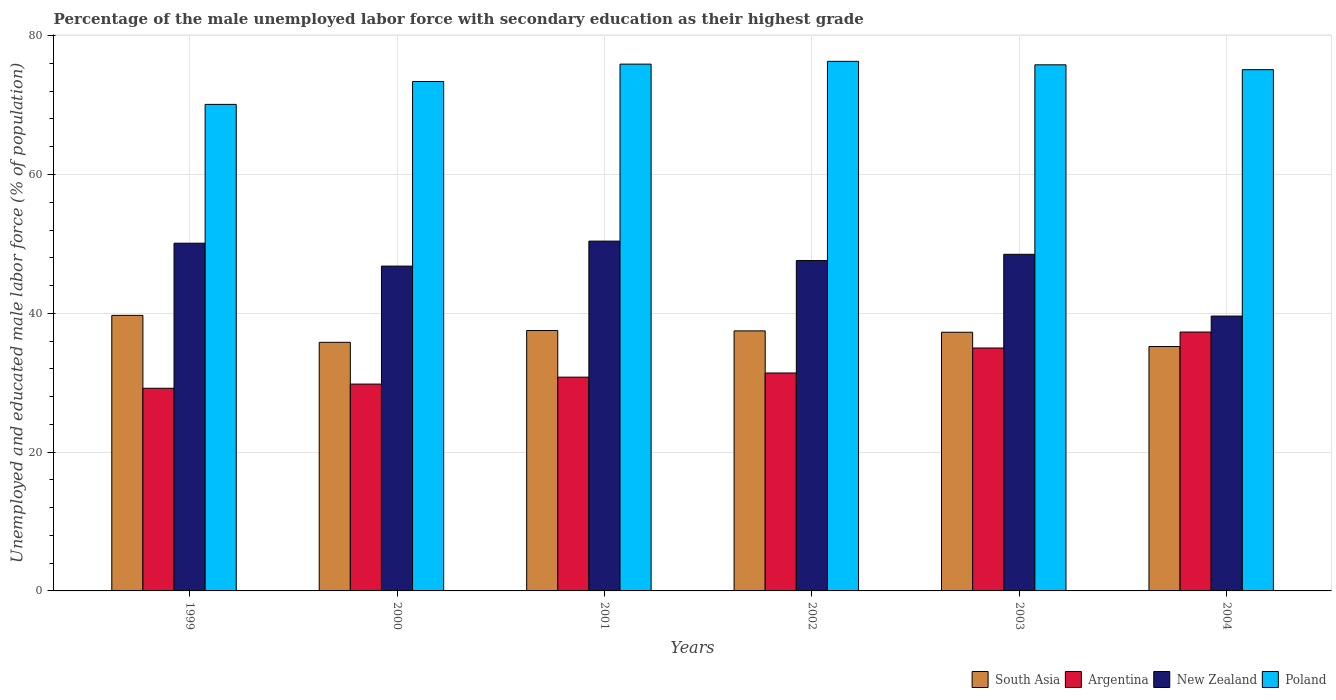Are the number of bars per tick equal to the number of legend labels?
Your answer should be compact. Yes. How many bars are there on the 5th tick from the left?
Your answer should be very brief. 4. What is the label of the 4th group of bars from the left?
Provide a short and direct response. 2002. What is the percentage of the unemployed male labor force with secondary education in South Asia in 2003?
Give a very brief answer. 37.27. Across all years, what is the maximum percentage of the unemployed male labor force with secondary education in South Asia?
Your response must be concise. 39.7. Across all years, what is the minimum percentage of the unemployed male labor force with secondary education in New Zealand?
Provide a succinct answer. 39.6. What is the total percentage of the unemployed male labor force with secondary education in Argentina in the graph?
Your answer should be very brief. 193.5. What is the difference between the percentage of the unemployed male labor force with secondary education in Argentina in 1999 and that in 2000?
Give a very brief answer. -0.6. What is the difference between the percentage of the unemployed male labor force with secondary education in South Asia in 2002 and the percentage of the unemployed male labor force with secondary education in Poland in 2004?
Keep it short and to the point. -37.63. What is the average percentage of the unemployed male labor force with secondary education in New Zealand per year?
Offer a very short reply. 47.17. In the year 2004, what is the difference between the percentage of the unemployed male labor force with secondary education in South Asia and percentage of the unemployed male labor force with secondary education in New Zealand?
Offer a very short reply. -4.39. What is the ratio of the percentage of the unemployed male labor force with secondary education in New Zealand in 1999 to that in 2004?
Your answer should be compact. 1.27. Is the percentage of the unemployed male labor force with secondary education in Poland in 1999 less than that in 2001?
Make the answer very short. Yes. What is the difference between the highest and the second highest percentage of the unemployed male labor force with secondary education in Poland?
Offer a very short reply. 0.4. What is the difference between the highest and the lowest percentage of the unemployed male labor force with secondary education in South Asia?
Offer a very short reply. 4.49. What does the 3rd bar from the left in 2003 represents?
Provide a short and direct response. New Zealand. What does the 2nd bar from the right in 2000 represents?
Give a very brief answer. New Zealand. How many bars are there?
Offer a very short reply. 24. How many years are there in the graph?
Provide a succinct answer. 6. Are the values on the major ticks of Y-axis written in scientific E-notation?
Your response must be concise. No. Does the graph contain any zero values?
Your answer should be very brief. No. Where does the legend appear in the graph?
Your response must be concise. Bottom right. What is the title of the graph?
Your answer should be compact. Percentage of the male unemployed labor force with secondary education as their highest grade. Does "Cabo Verde" appear as one of the legend labels in the graph?
Provide a succinct answer. No. What is the label or title of the Y-axis?
Provide a succinct answer. Unemployed and educated male labor force (% of population). What is the Unemployed and educated male labor force (% of population) of South Asia in 1999?
Offer a very short reply. 39.7. What is the Unemployed and educated male labor force (% of population) of Argentina in 1999?
Your answer should be compact. 29.2. What is the Unemployed and educated male labor force (% of population) in New Zealand in 1999?
Ensure brevity in your answer.  50.1. What is the Unemployed and educated male labor force (% of population) of Poland in 1999?
Provide a short and direct response. 70.1. What is the Unemployed and educated male labor force (% of population) of South Asia in 2000?
Your answer should be very brief. 35.82. What is the Unemployed and educated male labor force (% of population) of Argentina in 2000?
Offer a very short reply. 29.8. What is the Unemployed and educated male labor force (% of population) of New Zealand in 2000?
Your answer should be very brief. 46.8. What is the Unemployed and educated male labor force (% of population) in Poland in 2000?
Make the answer very short. 73.4. What is the Unemployed and educated male labor force (% of population) of South Asia in 2001?
Give a very brief answer. 37.52. What is the Unemployed and educated male labor force (% of population) of Argentina in 2001?
Provide a succinct answer. 30.8. What is the Unemployed and educated male labor force (% of population) of New Zealand in 2001?
Your answer should be very brief. 50.4. What is the Unemployed and educated male labor force (% of population) of Poland in 2001?
Keep it short and to the point. 75.9. What is the Unemployed and educated male labor force (% of population) of South Asia in 2002?
Keep it short and to the point. 37.47. What is the Unemployed and educated male labor force (% of population) of Argentina in 2002?
Offer a very short reply. 31.4. What is the Unemployed and educated male labor force (% of population) of New Zealand in 2002?
Ensure brevity in your answer.  47.6. What is the Unemployed and educated male labor force (% of population) in Poland in 2002?
Your answer should be very brief. 76.3. What is the Unemployed and educated male labor force (% of population) in South Asia in 2003?
Ensure brevity in your answer.  37.27. What is the Unemployed and educated male labor force (% of population) of New Zealand in 2003?
Your response must be concise. 48.5. What is the Unemployed and educated male labor force (% of population) in Poland in 2003?
Your response must be concise. 75.8. What is the Unemployed and educated male labor force (% of population) of South Asia in 2004?
Your answer should be very brief. 35.21. What is the Unemployed and educated male labor force (% of population) of Argentina in 2004?
Make the answer very short. 37.3. What is the Unemployed and educated male labor force (% of population) of New Zealand in 2004?
Give a very brief answer. 39.6. What is the Unemployed and educated male labor force (% of population) of Poland in 2004?
Your answer should be very brief. 75.1. Across all years, what is the maximum Unemployed and educated male labor force (% of population) of South Asia?
Provide a succinct answer. 39.7. Across all years, what is the maximum Unemployed and educated male labor force (% of population) of Argentina?
Provide a succinct answer. 37.3. Across all years, what is the maximum Unemployed and educated male labor force (% of population) of New Zealand?
Your response must be concise. 50.4. Across all years, what is the maximum Unemployed and educated male labor force (% of population) of Poland?
Make the answer very short. 76.3. Across all years, what is the minimum Unemployed and educated male labor force (% of population) of South Asia?
Offer a terse response. 35.21. Across all years, what is the minimum Unemployed and educated male labor force (% of population) of Argentina?
Make the answer very short. 29.2. Across all years, what is the minimum Unemployed and educated male labor force (% of population) in New Zealand?
Offer a terse response. 39.6. Across all years, what is the minimum Unemployed and educated male labor force (% of population) in Poland?
Provide a short and direct response. 70.1. What is the total Unemployed and educated male labor force (% of population) of South Asia in the graph?
Provide a succinct answer. 222.98. What is the total Unemployed and educated male labor force (% of population) in Argentina in the graph?
Make the answer very short. 193.5. What is the total Unemployed and educated male labor force (% of population) in New Zealand in the graph?
Ensure brevity in your answer.  283. What is the total Unemployed and educated male labor force (% of population) of Poland in the graph?
Provide a short and direct response. 446.6. What is the difference between the Unemployed and educated male labor force (% of population) of South Asia in 1999 and that in 2000?
Keep it short and to the point. 3.88. What is the difference between the Unemployed and educated male labor force (% of population) of Argentina in 1999 and that in 2000?
Keep it short and to the point. -0.6. What is the difference between the Unemployed and educated male labor force (% of population) of New Zealand in 1999 and that in 2000?
Keep it short and to the point. 3.3. What is the difference between the Unemployed and educated male labor force (% of population) of South Asia in 1999 and that in 2001?
Keep it short and to the point. 2.19. What is the difference between the Unemployed and educated male labor force (% of population) of South Asia in 1999 and that in 2002?
Offer a very short reply. 2.23. What is the difference between the Unemployed and educated male labor force (% of population) in Argentina in 1999 and that in 2002?
Give a very brief answer. -2.2. What is the difference between the Unemployed and educated male labor force (% of population) of New Zealand in 1999 and that in 2002?
Keep it short and to the point. 2.5. What is the difference between the Unemployed and educated male labor force (% of population) of Poland in 1999 and that in 2002?
Keep it short and to the point. -6.2. What is the difference between the Unemployed and educated male labor force (% of population) in South Asia in 1999 and that in 2003?
Keep it short and to the point. 2.43. What is the difference between the Unemployed and educated male labor force (% of population) in Argentina in 1999 and that in 2003?
Keep it short and to the point. -5.8. What is the difference between the Unemployed and educated male labor force (% of population) of South Asia in 1999 and that in 2004?
Keep it short and to the point. 4.49. What is the difference between the Unemployed and educated male labor force (% of population) of Poland in 1999 and that in 2004?
Keep it short and to the point. -5. What is the difference between the Unemployed and educated male labor force (% of population) in South Asia in 2000 and that in 2001?
Provide a succinct answer. -1.7. What is the difference between the Unemployed and educated male labor force (% of population) of Poland in 2000 and that in 2001?
Your answer should be compact. -2.5. What is the difference between the Unemployed and educated male labor force (% of population) of South Asia in 2000 and that in 2002?
Provide a succinct answer. -1.65. What is the difference between the Unemployed and educated male labor force (% of population) of South Asia in 2000 and that in 2003?
Your answer should be compact. -1.45. What is the difference between the Unemployed and educated male labor force (% of population) in South Asia in 2000 and that in 2004?
Your response must be concise. 0.6. What is the difference between the Unemployed and educated male labor force (% of population) in Argentina in 2000 and that in 2004?
Provide a short and direct response. -7.5. What is the difference between the Unemployed and educated male labor force (% of population) of New Zealand in 2000 and that in 2004?
Offer a terse response. 7.2. What is the difference between the Unemployed and educated male labor force (% of population) in Poland in 2000 and that in 2004?
Provide a succinct answer. -1.7. What is the difference between the Unemployed and educated male labor force (% of population) of South Asia in 2001 and that in 2002?
Ensure brevity in your answer.  0.05. What is the difference between the Unemployed and educated male labor force (% of population) of Argentina in 2001 and that in 2002?
Provide a succinct answer. -0.6. What is the difference between the Unemployed and educated male labor force (% of population) in Poland in 2001 and that in 2002?
Offer a very short reply. -0.4. What is the difference between the Unemployed and educated male labor force (% of population) of South Asia in 2001 and that in 2003?
Keep it short and to the point. 0.25. What is the difference between the Unemployed and educated male labor force (% of population) of Poland in 2001 and that in 2003?
Ensure brevity in your answer.  0.1. What is the difference between the Unemployed and educated male labor force (% of population) in South Asia in 2001 and that in 2004?
Provide a succinct answer. 2.3. What is the difference between the Unemployed and educated male labor force (% of population) of Argentina in 2001 and that in 2004?
Your response must be concise. -6.5. What is the difference between the Unemployed and educated male labor force (% of population) in New Zealand in 2001 and that in 2004?
Offer a terse response. 10.8. What is the difference between the Unemployed and educated male labor force (% of population) in South Asia in 2002 and that in 2003?
Ensure brevity in your answer.  0.2. What is the difference between the Unemployed and educated male labor force (% of population) in New Zealand in 2002 and that in 2003?
Provide a short and direct response. -0.9. What is the difference between the Unemployed and educated male labor force (% of population) of Poland in 2002 and that in 2003?
Offer a very short reply. 0.5. What is the difference between the Unemployed and educated male labor force (% of population) of South Asia in 2002 and that in 2004?
Provide a succinct answer. 2.25. What is the difference between the Unemployed and educated male labor force (% of population) in New Zealand in 2002 and that in 2004?
Offer a very short reply. 8. What is the difference between the Unemployed and educated male labor force (% of population) of Poland in 2002 and that in 2004?
Your answer should be compact. 1.2. What is the difference between the Unemployed and educated male labor force (% of population) in South Asia in 2003 and that in 2004?
Provide a short and direct response. 2.05. What is the difference between the Unemployed and educated male labor force (% of population) in South Asia in 1999 and the Unemployed and educated male labor force (% of population) in New Zealand in 2000?
Your answer should be very brief. -7.1. What is the difference between the Unemployed and educated male labor force (% of population) of South Asia in 1999 and the Unemployed and educated male labor force (% of population) of Poland in 2000?
Provide a succinct answer. -33.7. What is the difference between the Unemployed and educated male labor force (% of population) in Argentina in 1999 and the Unemployed and educated male labor force (% of population) in New Zealand in 2000?
Make the answer very short. -17.6. What is the difference between the Unemployed and educated male labor force (% of population) in Argentina in 1999 and the Unemployed and educated male labor force (% of population) in Poland in 2000?
Your response must be concise. -44.2. What is the difference between the Unemployed and educated male labor force (% of population) in New Zealand in 1999 and the Unemployed and educated male labor force (% of population) in Poland in 2000?
Your answer should be compact. -23.3. What is the difference between the Unemployed and educated male labor force (% of population) of South Asia in 1999 and the Unemployed and educated male labor force (% of population) of Poland in 2001?
Provide a succinct answer. -36.2. What is the difference between the Unemployed and educated male labor force (% of population) in Argentina in 1999 and the Unemployed and educated male labor force (% of population) in New Zealand in 2001?
Your response must be concise. -21.2. What is the difference between the Unemployed and educated male labor force (% of population) of Argentina in 1999 and the Unemployed and educated male labor force (% of population) of Poland in 2001?
Offer a terse response. -46.7. What is the difference between the Unemployed and educated male labor force (% of population) of New Zealand in 1999 and the Unemployed and educated male labor force (% of population) of Poland in 2001?
Keep it short and to the point. -25.8. What is the difference between the Unemployed and educated male labor force (% of population) in South Asia in 1999 and the Unemployed and educated male labor force (% of population) in Argentina in 2002?
Offer a terse response. 8.3. What is the difference between the Unemployed and educated male labor force (% of population) of South Asia in 1999 and the Unemployed and educated male labor force (% of population) of Poland in 2002?
Ensure brevity in your answer.  -36.6. What is the difference between the Unemployed and educated male labor force (% of population) in Argentina in 1999 and the Unemployed and educated male labor force (% of population) in New Zealand in 2002?
Provide a succinct answer. -18.4. What is the difference between the Unemployed and educated male labor force (% of population) in Argentina in 1999 and the Unemployed and educated male labor force (% of population) in Poland in 2002?
Your answer should be very brief. -47.1. What is the difference between the Unemployed and educated male labor force (% of population) of New Zealand in 1999 and the Unemployed and educated male labor force (% of population) of Poland in 2002?
Offer a very short reply. -26.2. What is the difference between the Unemployed and educated male labor force (% of population) in South Asia in 1999 and the Unemployed and educated male labor force (% of population) in Poland in 2003?
Your response must be concise. -36.1. What is the difference between the Unemployed and educated male labor force (% of population) of Argentina in 1999 and the Unemployed and educated male labor force (% of population) of New Zealand in 2003?
Your answer should be compact. -19.3. What is the difference between the Unemployed and educated male labor force (% of population) in Argentina in 1999 and the Unemployed and educated male labor force (% of population) in Poland in 2003?
Your answer should be very brief. -46.6. What is the difference between the Unemployed and educated male labor force (% of population) of New Zealand in 1999 and the Unemployed and educated male labor force (% of population) of Poland in 2003?
Your answer should be very brief. -25.7. What is the difference between the Unemployed and educated male labor force (% of population) of South Asia in 1999 and the Unemployed and educated male labor force (% of population) of New Zealand in 2004?
Ensure brevity in your answer.  0.1. What is the difference between the Unemployed and educated male labor force (% of population) of South Asia in 1999 and the Unemployed and educated male labor force (% of population) of Poland in 2004?
Provide a short and direct response. -35.4. What is the difference between the Unemployed and educated male labor force (% of population) in Argentina in 1999 and the Unemployed and educated male labor force (% of population) in Poland in 2004?
Keep it short and to the point. -45.9. What is the difference between the Unemployed and educated male labor force (% of population) of South Asia in 2000 and the Unemployed and educated male labor force (% of population) of Argentina in 2001?
Your answer should be very brief. 5.02. What is the difference between the Unemployed and educated male labor force (% of population) of South Asia in 2000 and the Unemployed and educated male labor force (% of population) of New Zealand in 2001?
Offer a very short reply. -14.58. What is the difference between the Unemployed and educated male labor force (% of population) of South Asia in 2000 and the Unemployed and educated male labor force (% of population) of Poland in 2001?
Offer a terse response. -40.08. What is the difference between the Unemployed and educated male labor force (% of population) of Argentina in 2000 and the Unemployed and educated male labor force (% of population) of New Zealand in 2001?
Give a very brief answer. -20.6. What is the difference between the Unemployed and educated male labor force (% of population) of Argentina in 2000 and the Unemployed and educated male labor force (% of population) of Poland in 2001?
Make the answer very short. -46.1. What is the difference between the Unemployed and educated male labor force (% of population) of New Zealand in 2000 and the Unemployed and educated male labor force (% of population) of Poland in 2001?
Your response must be concise. -29.1. What is the difference between the Unemployed and educated male labor force (% of population) in South Asia in 2000 and the Unemployed and educated male labor force (% of population) in Argentina in 2002?
Make the answer very short. 4.42. What is the difference between the Unemployed and educated male labor force (% of population) in South Asia in 2000 and the Unemployed and educated male labor force (% of population) in New Zealand in 2002?
Your answer should be very brief. -11.78. What is the difference between the Unemployed and educated male labor force (% of population) in South Asia in 2000 and the Unemployed and educated male labor force (% of population) in Poland in 2002?
Your answer should be very brief. -40.48. What is the difference between the Unemployed and educated male labor force (% of population) of Argentina in 2000 and the Unemployed and educated male labor force (% of population) of New Zealand in 2002?
Keep it short and to the point. -17.8. What is the difference between the Unemployed and educated male labor force (% of population) in Argentina in 2000 and the Unemployed and educated male labor force (% of population) in Poland in 2002?
Offer a terse response. -46.5. What is the difference between the Unemployed and educated male labor force (% of population) of New Zealand in 2000 and the Unemployed and educated male labor force (% of population) of Poland in 2002?
Your response must be concise. -29.5. What is the difference between the Unemployed and educated male labor force (% of population) of South Asia in 2000 and the Unemployed and educated male labor force (% of population) of Argentina in 2003?
Your answer should be very brief. 0.82. What is the difference between the Unemployed and educated male labor force (% of population) in South Asia in 2000 and the Unemployed and educated male labor force (% of population) in New Zealand in 2003?
Ensure brevity in your answer.  -12.68. What is the difference between the Unemployed and educated male labor force (% of population) in South Asia in 2000 and the Unemployed and educated male labor force (% of population) in Poland in 2003?
Your answer should be compact. -39.98. What is the difference between the Unemployed and educated male labor force (% of population) of Argentina in 2000 and the Unemployed and educated male labor force (% of population) of New Zealand in 2003?
Give a very brief answer. -18.7. What is the difference between the Unemployed and educated male labor force (% of population) of Argentina in 2000 and the Unemployed and educated male labor force (% of population) of Poland in 2003?
Your answer should be compact. -46. What is the difference between the Unemployed and educated male labor force (% of population) in New Zealand in 2000 and the Unemployed and educated male labor force (% of population) in Poland in 2003?
Offer a very short reply. -29. What is the difference between the Unemployed and educated male labor force (% of population) in South Asia in 2000 and the Unemployed and educated male labor force (% of population) in Argentina in 2004?
Your answer should be compact. -1.48. What is the difference between the Unemployed and educated male labor force (% of population) in South Asia in 2000 and the Unemployed and educated male labor force (% of population) in New Zealand in 2004?
Your response must be concise. -3.78. What is the difference between the Unemployed and educated male labor force (% of population) in South Asia in 2000 and the Unemployed and educated male labor force (% of population) in Poland in 2004?
Your answer should be very brief. -39.28. What is the difference between the Unemployed and educated male labor force (% of population) in Argentina in 2000 and the Unemployed and educated male labor force (% of population) in New Zealand in 2004?
Ensure brevity in your answer.  -9.8. What is the difference between the Unemployed and educated male labor force (% of population) in Argentina in 2000 and the Unemployed and educated male labor force (% of population) in Poland in 2004?
Provide a succinct answer. -45.3. What is the difference between the Unemployed and educated male labor force (% of population) of New Zealand in 2000 and the Unemployed and educated male labor force (% of population) of Poland in 2004?
Keep it short and to the point. -28.3. What is the difference between the Unemployed and educated male labor force (% of population) of South Asia in 2001 and the Unemployed and educated male labor force (% of population) of Argentina in 2002?
Offer a terse response. 6.12. What is the difference between the Unemployed and educated male labor force (% of population) in South Asia in 2001 and the Unemployed and educated male labor force (% of population) in New Zealand in 2002?
Give a very brief answer. -10.09. What is the difference between the Unemployed and educated male labor force (% of population) in South Asia in 2001 and the Unemployed and educated male labor force (% of population) in Poland in 2002?
Keep it short and to the point. -38.78. What is the difference between the Unemployed and educated male labor force (% of population) of Argentina in 2001 and the Unemployed and educated male labor force (% of population) of New Zealand in 2002?
Provide a succinct answer. -16.8. What is the difference between the Unemployed and educated male labor force (% of population) of Argentina in 2001 and the Unemployed and educated male labor force (% of population) of Poland in 2002?
Make the answer very short. -45.5. What is the difference between the Unemployed and educated male labor force (% of population) of New Zealand in 2001 and the Unemployed and educated male labor force (% of population) of Poland in 2002?
Ensure brevity in your answer.  -25.9. What is the difference between the Unemployed and educated male labor force (% of population) in South Asia in 2001 and the Unemployed and educated male labor force (% of population) in Argentina in 2003?
Make the answer very short. 2.52. What is the difference between the Unemployed and educated male labor force (% of population) of South Asia in 2001 and the Unemployed and educated male labor force (% of population) of New Zealand in 2003?
Your answer should be compact. -10.98. What is the difference between the Unemployed and educated male labor force (% of population) in South Asia in 2001 and the Unemployed and educated male labor force (% of population) in Poland in 2003?
Provide a short and direct response. -38.28. What is the difference between the Unemployed and educated male labor force (% of population) of Argentina in 2001 and the Unemployed and educated male labor force (% of population) of New Zealand in 2003?
Offer a terse response. -17.7. What is the difference between the Unemployed and educated male labor force (% of population) of Argentina in 2001 and the Unemployed and educated male labor force (% of population) of Poland in 2003?
Offer a very short reply. -45. What is the difference between the Unemployed and educated male labor force (% of population) in New Zealand in 2001 and the Unemployed and educated male labor force (% of population) in Poland in 2003?
Your answer should be compact. -25.4. What is the difference between the Unemployed and educated male labor force (% of population) in South Asia in 2001 and the Unemployed and educated male labor force (% of population) in Argentina in 2004?
Your response must be concise. 0.21. What is the difference between the Unemployed and educated male labor force (% of population) in South Asia in 2001 and the Unemployed and educated male labor force (% of population) in New Zealand in 2004?
Offer a terse response. -2.08. What is the difference between the Unemployed and educated male labor force (% of population) in South Asia in 2001 and the Unemployed and educated male labor force (% of population) in Poland in 2004?
Your response must be concise. -37.59. What is the difference between the Unemployed and educated male labor force (% of population) of Argentina in 2001 and the Unemployed and educated male labor force (% of population) of Poland in 2004?
Make the answer very short. -44.3. What is the difference between the Unemployed and educated male labor force (% of population) in New Zealand in 2001 and the Unemployed and educated male labor force (% of population) in Poland in 2004?
Ensure brevity in your answer.  -24.7. What is the difference between the Unemployed and educated male labor force (% of population) in South Asia in 2002 and the Unemployed and educated male labor force (% of population) in Argentina in 2003?
Offer a terse response. 2.47. What is the difference between the Unemployed and educated male labor force (% of population) in South Asia in 2002 and the Unemployed and educated male labor force (% of population) in New Zealand in 2003?
Make the answer very short. -11.03. What is the difference between the Unemployed and educated male labor force (% of population) in South Asia in 2002 and the Unemployed and educated male labor force (% of population) in Poland in 2003?
Offer a terse response. -38.33. What is the difference between the Unemployed and educated male labor force (% of population) of Argentina in 2002 and the Unemployed and educated male labor force (% of population) of New Zealand in 2003?
Your answer should be compact. -17.1. What is the difference between the Unemployed and educated male labor force (% of population) in Argentina in 2002 and the Unemployed and educated male labor force (% of population) in Poland in 2003?
Keep it short and to the point. -44.4. What is the difference between the Unemployed and educated male labor force (% of population) in New Zealand in 2002 and the Unemployed and educated male labor force (% of population) in Poland in 2003?
Your answer should be compact. -28.2. What is the difference between the Unemployed and educated male labor force (% of population) in South Asia in 2002 and the Unemployed and educated male labor force (% of population) in Argentina in 2004?
Provide a succinct answer. 0.17. What is the difference between the Unemployed and educated male labor force (% of population) of South Asia in 2002 and the Unemployed and educated male labor force (% of population) of New Zealand in 2004?
Provide a succinct answer. -2.13. What is the difference between the Unemployed and educated male labor force (% of population) in South Asia in 2002 and the Unemployed and educated male labor force (% of population) in Poland in 2004?
Offer a terse response. -37.63. What is the difference between the Unemployed and educated male labor force (% of population) of Argentina in 2002 and the Unemployed and educated male labor force (% of population) of New Zealand in 2004?
Give a very brief answer. -8.2. What is the difference between the Unemployed and educated male labor force (% of population) of Argentina in 2002 and the Unemployed and educated male labor force (% of population) of Poland in 2004?
Your response must be concise. -43.7. What is the difference between the Unemployed and educated male labor force (% of population) of New Zealand in 2002 and the Unemployed and educated male labor force (% of population) of Poland in 2004?
Your answer should be compact. -27.5. What is the difference between the Unemployed and educated male labor force (% of population) of South Asia in 2003 and the Unemployed and educated male labor force (% of population) of Argentina in 2004?
Provide a succinct answer. -0.03. What is the difference between the Unemployed and educated male labor force (% of population) in South Asia in 2003 and the Unemployed and educated male labor force (% of population) in New Zealand in 2004?
Provide a short and direct response. -2.33. What is the difference between the Unemployed and educated male labor force (% of population) in South Asia in 2003 and the Unemployed and educated male labor force (% of population) in Poland in 2004?
Give a very brief answer. -37.83. What is the difference between the Unemployed and educated male labor force (% of population) in Argentina in 2003 and the Unemployed and educated male labor force (% of population) in New Zealand in 2004?
Provide a short and direct response. -4.6. What is the difference between the Unemployed and educated male labor force (% of population) in Argentina in 2003 and the Unemployed and educated male labor force (% of population) in Poland in 2004?
Provide a succinct answer. -40.1. What is the difference between the Unemployed and educated male labor force (% of population) of New Zealand in 2003 and the Unemployed and educated male labor force (% of population) of Poland in 2004?
Ensure brevity in your answer.  -26.6. What is the average Unemployed and educated male labor force (% of population) of South Asia per year?
Your answer should be compact. 37.16. What is the average Unemployed and educated male labor force (% of population) in Argentina per year?
Your answer should be compact. 32.25. What is the average Unemployed and educated male labor force (% of population) of New Zealand per year?
Offer a very short reply. 47.17. What is the average Unemployed and educated male labor force (% of population) of Poland per year?
Provide a succinct answer. 74.43. In the year 1999, what is the difference between the Unemployed and educated male labor force (% of population) in South Asia and Unemployed and educated male labor force (% of population) in Argentina?
Provide a succinct answer. 10.5. In the year 1999, what is the difference between the Unemployed and educated male labor force (% of population) in South Asia and Unemployed and educated male labor force (% of population) in Poland?
Provide a short and direct response. -30.4. In the year 1999, what is the difference between the Unemployed and educated male labor force (% of population) of Argentina and Unemployed and educated male labor force (% of population) of New Zealand?
Offer a terse response. -20.9. In the year 1999, what is the difference between the Unemployed and educated male labor force (% of population) in Argentina and Unemployed and educated male labor force (% of population) in Poland?
Give a very brief answer. -40.9. In the year 2000, what is the difference between the Unemployed and educated male labor force (% of population) in South Asia and Unemployed and educated male labor force (% of population) in Argentina?
Offer a very short reply. 6.02. In the year 2000, what is the difference between the Unemployed and educated male labor force (% of population) of South Asia and Unemployed and educated male labor force (% of population) of New Zealand?
Provide a short and direct response. -10.98. In the year 2000, what is the difference between the Unemployed and educated male labor force (% of population) in South Asia and Unemployed and educated male labor force (% of population) in Poland?
Offer a terse response. -37.58. In the year 2000, what is the difference between the Unemployed and educated male labor force (% of population) in Argentina and Unemployed and educated male labor force (% of population) in Poland?
Your answer should be very brief. -43.6. In the year 2000, what is the difference between the Unemployed and educated male labor force (% of population) of New Zealand and Unemployed and educated male labor force (% of population) of Poland?
Offer a terse response. -26.6. In the year 2001, what is the difference between the Unemployed and educated male labor force (% of population) in South Asia and Unemployed and educated male labor force (% of population) in Argentina?
Ensure brevity in your answer.  6.71. In the year 2001, what is the difference between the Unemployed and educated male labor force (% of population) of South Asia and Unemployed and educated male labor force (% of population) of New Zealand?
Provide a succinct answer. -12.88. In the year 2001, what is the difference between the Unemployed and educated male labor force (% of population) of South Asia and Unemployed and educated male labor force (% of population) of Poland?
Provide a succinct answer. -38.38. In the year 2001, what is the difference between the Unemployed and educated male labor force (% of population) in Argentina and Unemployed and educated male labor force (% of population) in New Zealand?
Your answer should be very brief. -19.6. In the year 2001, what is the difference between the Unemployed and educated male labor force (% of population) in Argentina and Unemployed and educated male labor force (% of population) in Poland?
Give a very brief answer. -45.1. In the year 2001, what is the difference between the Unemployed and educated male labor force (% of population) in New Zealand and Unemployed and educated male labor force (% of population) in Poland?
Your answer should be compact. -25.5. In the year 2002, what is the difference between the Unemployed and educated male labor force (% of population) in South Asia and Unemployed and educated male labor force (% of population) in Argentina?
Offer a terse response. 6.07. In the year 2002, what is the difference between the Unemployed and educated male labor force (% of population) in South Asia and Unemployed and educated male labor force (% of population) in New Zealand?
Your answer should be compact. -10.13. In the year 2002, what is the difference between the Unemployed and educated male labor force (% of population) of South Asia and Unemployed and educated male labor force (% of population) of Poland?
Your answer should be compact. -38.83. In the year 2002, what is the difference between the Unemployed and educated male labor force (% of population) in Argentina and Unemployed and educated male labor force (% of population) in New Zealand?
Your response must be concise. -16.2. In the year 2002, what is the difference between the Unemployed and educated male labor force (% of population) in Argentina and Unemployed and educated male labor force (% of population) in Poland?
Offer a very short reply. -44.9. In the year 2002, what is the difference between the Unemployed and educated male labor force (% of population) in New Zealand and Unemployed and educated male labor force (% of population) in Poland?
Keep it short and to the point. -28.7. In the year 2003, what is the difference between the Unemployed and educated male labor force (% of population) in South Asia and Unemployed and educated male labor force (% of population) in Argentina?
Give a very brief answer. 2.27. In the year 2003, what is the difference between the Unemployed and educated male labor force (% of population) of South Asia and Unemployed and educated male labor force (% of population) of New Zealand?
Offer a terse response. -11.23. In the year 2003, what is the difference between the Unemployed and educated male labor force (% of population) of South Asia and Unemployed and educated male labor force (% of population) of Poland?
Give a very brief answer. -38.53. In the year 2003, what is the difference between the Unemployed and educated male labor force (% of population) of Argentina and Unemployed and educated male labor force (% of population) of Poland?
Give a very brief answer. -40.8. In the year 2003, what is the difference between the Unemployed and educated male labor force (% of population) in New Zealand and Unemployed and educated male labor force (% of population) in Poland?
Offer a terse response. -27.3. In the year 2004, what is the difference between the Unemployed and educated male labor force (% of population) in South Asia and Unemployed and educated male labor force (% of population) in Argentina?
Provide a succinct answer. -2.09. In the year 2004, what is the difference between the Unemployed and educated male labor force (% of population) in South Asia and Unemployed and educated male labor force (% of population) in New Zealand?
Ensure brevity in your answer.  -4.39. In the year 2004, what is the difference between the Unemployed and educated male labor force (% of population) in South Asia and Unemployed and educated male labor force (% of population) in Poland?
Provide a succinct answer. -39.89. In the year 2004, what is the difference between the Unemployed and educated male labor force (% of population) of Argentina and Unemployed and educated male labor force (% of population) of Poland?
Make the answer very short. -37.8. In the year 2004, what is the difference between the Unemployed and educated male labor force (% of population) in New Zealand and Unemployed and educated male labor force (% of population) in Poland?
Make the answer very short. -35.5. What is the ratio of the Unemployed and educated male labor force (% of population) of South Asia in 1999 to that in 2000?
Keep it short and to the point. 1.11. What is the ratio of the Unemployed and educated male labor force (% of population) in Argentina in 1999 to that in 2000?
Give a very brief answer. 0.98. What is the ratio of the Unemployed and educated male labor force (% of population) in New Zealand in 1999 to that in 2000?
Your answer should be compact. 1.07. What is the ratio of the Unemployed and educated male labor force (% of population) of Poland in 1999 to that in 2000?
Provide a succinct answer. 0.95. What is the ratio of the Unemployed and educated male labor force (% of population) in South Asia in 1999 to that in 2001?
Keep it short and to the point. 1.06. What is the ratio of the Unemployed and educated male labor force (% of population) in Argentina in 1999 to that in 2001?
Provide a short and direct response. 0.95. What is the ratio of the Unemployed and educated male labor force (% of population) in Poland in 1999 to that in 2001?
Offer a terse response. 0.92. What is the ratio of the Unemployed and educated male labor force (% of population) in South Asia in 1999 to that in 2002?
Provide a succinct answer. 1.06. What is the ratio of the Unemployed and educated male labor force (% of population) of Argentina in 1999 to that in 2002?
Provide a succinct answer. 0.93. What is the ratio of the Unemployed and educated male labor force (% of population) of New Zealand in 1999 to that in 2002?
Make the answer very short. 1.05. What is the ratio of the Unemployed and educated male labor force (% of population) in Poland in 1999 to that in 2002?
Your answer should be very brief. 0.92. What is the ratio of the Unemployed and educated male labor force (% of population) in South Asia in 1999 to that in 2003?
Ensure brevity in your answer.  1.07. What is the ratio of the Unemployed and educated male labor force (% of population) of Argentina in 1999 to that in 2003?
Offer a terse response. 0.83. What is the ratio of the Unemployed and educated male labor force (% of population) of New Zealand in 1999 to that in 2003?
Give a very brief answer. 1.03. What is the ratio of the Unemployed and educated male labor force (% of population) of Poland in 1999 to that in 2003?
Offer a terse response. 0.92. What is the ratio of the Unemployed and educated male labor force (% of population) in South Asia in 1999 to that in 2004?
Your response must be concise. 1.13. What is the ratio of the Unemployed and educated male labor force (% of population) of Argentina in 1999 to that in 2004?
Keep it short and to the point. 0.78. What is the ratio of the Unemployed and educated male labor force (% of population) in New Zealand in 1999 to that in 2004?
Give a very brief answer. 1.27. What is the ratio of the Unemployed and educated male labor force (% of population) in Poland in 1999 to that in 2004?
Provide a succinct answer. 0.93. What is the ratio of the Unemployed and educated male labor force (% of population) of South Asia in 2000 to that in 2001?
Provide a short and direct response. 0.95. What is the ratio of the Unemployed and educated male labor force (% of population) in Argentina in 2000 to that in 2001?
Your response must be concise. 0.97. What is the ratio of the Unemployed and educated male labor force (% of population) in Poland in 2000 to that in 2001?
Make the answer very short. 0.97. What is the ratio of the Unemployed and educated male labor force (% of population) of South Asia in 2000 to that in 2002?
Your answer should be very brief. 0.96. What is the ratio of the Unemployed and educated male labor force (% of population) in Argentina in 2000 to that in 2002?
Offer a terse response. 0.95. What is the ratio of the Unemployed and educated male labor force (% of population) of New Zealand in 2000 to that in 2002?
Provide a short and direct response. 0.98. What is the ratio of the Unemployed and educated male labor force (% of population) in Poland in 2000 to that in 2002?
Your response must be concise. 0.96. What is the ratio of the Unemployed and educated male labor force (% of population) in South Asia in 2000 to that in 2003?
Your answer should be compact. 0.96. What is the ratio of the Unemployed and educated male labor force (% of population) in Argentina in 2000 to that in 2003?
Offer a terse response. 0.85. What is the ratio of the Unemployed and educated male labor force (% of population) in New Zealand in 2000 to that in 2003?
Provide a short and direct response. 0.96. What is the ratio of the Unemployed and educated male labor force (% of population) of Poland in 2000 to that in 2003?
Give a very brief answer. 0.97. What is the ratio of the Unemployed and educated male labor force (% of population) of South Asia in 2000 to that in 2004?
Provide a short and direct response. 1.02. What is the ratio of the Unemployed and educated male labor force (% of population) of Argentina in 2000 to that in 2004?
Your answer should be very brief. 0.8. What is the ratio of the Unemployed and educated male labor force (% of population) in New Zealand in 2000 to that in 2004?
Make the answer very short. 1.18. What is the ratio of the Unemployed and educated male labor force (% of population) in Poland in 2000 to that in 2004?
Make the answer very short. 0.98. What is the ratio of the Unemployed and educated male labor force (% of population) of Argentina in 2001 to that in 2002?
Provide a succinct answer. 0.98. What is the ratio of the Unemployed and educated male labor force (% of population) in New Zealand in 2001 to that in 2002?
Keep it short and to the point. 1.06. What is the ratio of the Unemployed and educated male labor force (% of population) of Poland in 2001 to that in 2002?
Make the answer very short. 0.99. What is the ratio of the Unemployed and educated male labor force (% of population) of South Asia in 2001 to that in 2003?
Ensure brevity in your answer.  1.01. What is the ratio of the Unemployed and educated male labor force (% of population) of Argentina in 2001 to that in 2003?
Offer a terse response. 0.88. What is the ratio of the Unemployed and educated male labor force (% of population) in New Zealand in 2001 to that in 2003?
Your answer should be compact. 1.04. What is the ratio of the Unemployed and educated male labor force (% of population) in South Asia in 2001 to that in 2004?
Offer a very short reply. 1.07. What is the ratio of the Unemployed and educated male labor force (% of population) in Argentina in 2001 to that in 2004?
Provide a succinct answer. 0.83. What is the ratio of the Unemployed and educated male labor force (% of population) in New Zealand in 2001 to that in 2004?
Offer a very short reply. 1.27. What is the ratio of the Unemployed and educated male labor force (% of population) of Poland in 2001 to that in 2004?
Give a very brief answer. 1.01. What is the ratio of the Unemployed and educated male labor force (% of population) of Argentina in 2002 to that in 2003?
Offer a terse response. 0.9. What is the ratio of the Unemployed and educated male labor force (% of population) in New Zealand in 2002 to that in 2003?
Keep it short and to the point. 0.98. What is the ratio of the Unemployed and educated male labor force (% of population) of Poland in 2002 to that in 2003?
Your response must be concise. 1.01. What is the ratio of the Unemployed and educated male labor force (% of population) of South Asia in 2002 to that in 2004?
Provide a short and direct response. 1.06. What is the ratio of the Unemployed and educated male labor force (% of population) in Argentina in 2002 to that in 2004?
Your answer should be compact. 0.84. What is the ratio of the Unemployed and educated male labor force (% of population) in New Zealand in 2002 to that in 2004?
Provide a short and direct response. 1.2. What is the ratio of the Unemployed and educated male labor force (% of population) in Poland in 2002 to that in 2004?
Provide a succinct answer. 1.02. What is the ratio of the Unemployed and educated male labor force (% of population) of South Asia in 2003 to that in 2004?
Your answer should be very brief. 1.06. What is the ratio of the Unemployed and educated male labor force (% of population) of Argentina in 2003 to that in 2004?
Keep it short and to the point. 0.94. What is the ratio of the Unemployed and educated male labor force (% of population) in New Zealand in 2003 to that in 2004?
Keep it short and to the point. 1.22. What is the ratio of the Unemployed and educated male labor force (% of population) in Poland in 2003 to that in 2004?
Ensure brevity in your answer.  1.01. What is the difference between the highest and the second highest Unemployed and educated male labor force (% of population) in South Asia?
Provide a succinct answer. 2.19. What is the difference between the highest and the second highest Unemployed and educated male labor force (% of population) in Poland?
Offer a very short reply. 0.4. What is the difference between the highest and the lowest Unemployed and educated male labor force (% of population) of South Asia?
Give a very brief answer. 4.49. What is the difference between the highest and the lowest Unemployed and educated male labor force (% of population) of New Zealand?
Give a very brief answer. 10.8. 